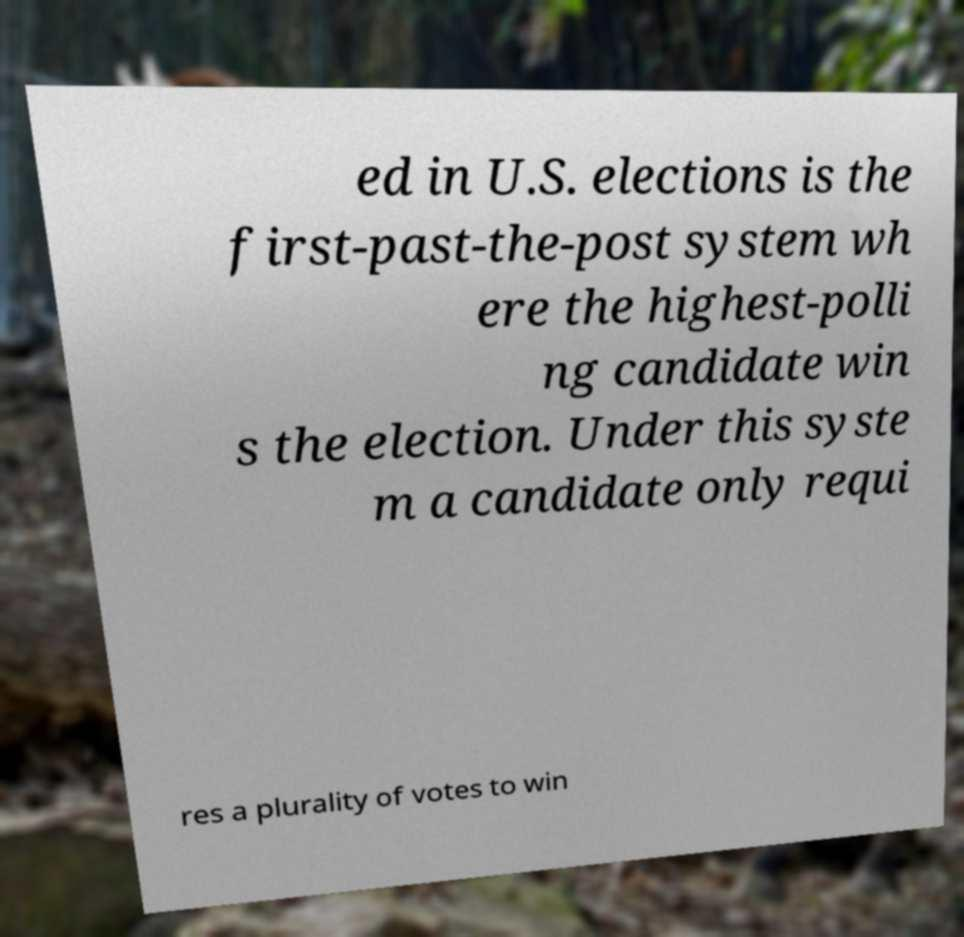Can you accurately transcribe the text from the provided image for me? ed in U.S. elections is the first-past-the-post system wh ere the highest-polli ng candidate win s the election. Under this syste m a candidate only requi res a plurality of votes to win 